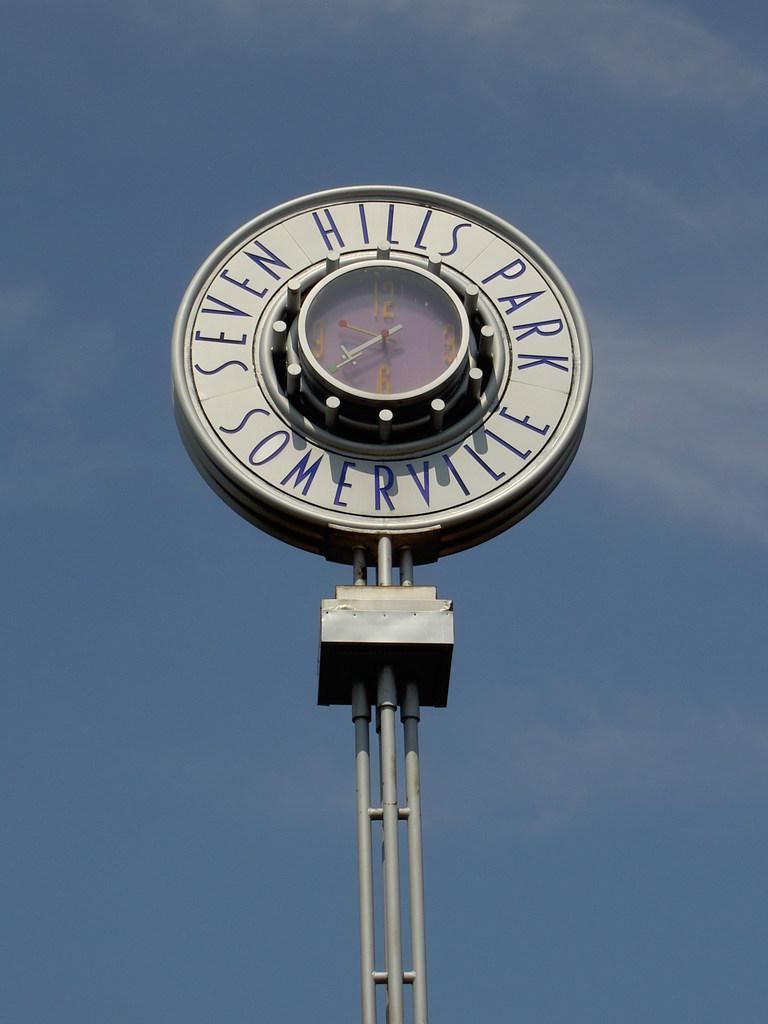Provide a one-sentence caption for the provided image. A clock from the Seven Hills Park in Somerville is shown on a mostly clear day. 